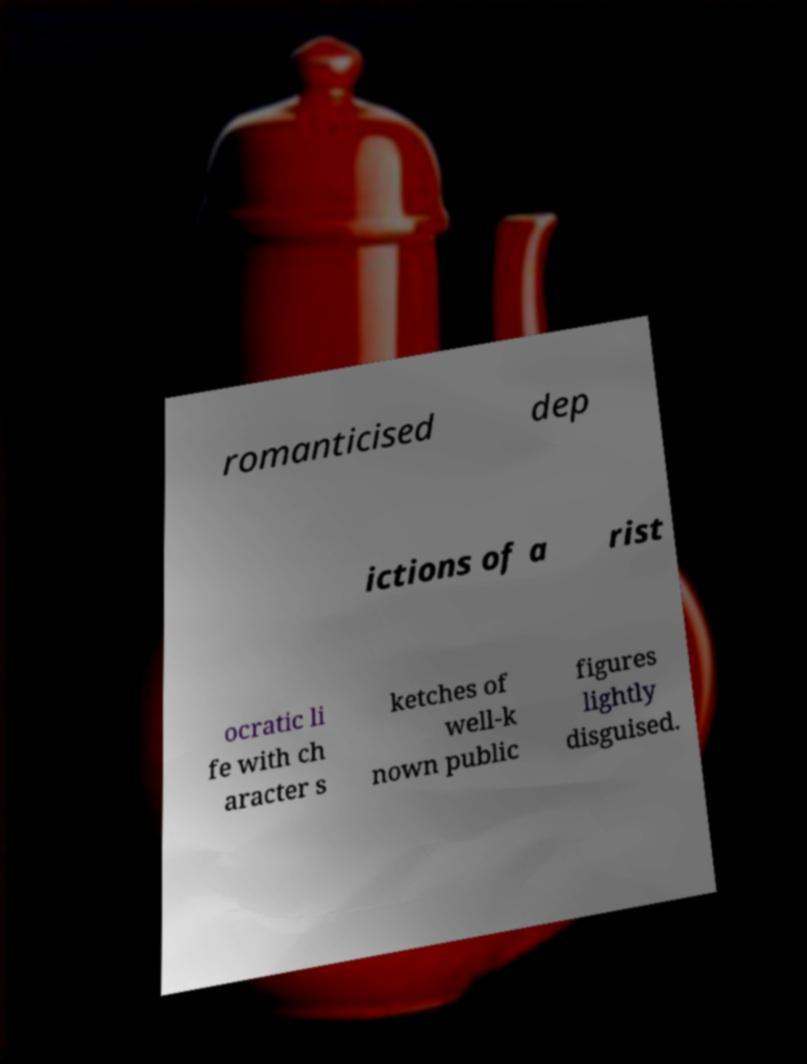What messages or text are displayed in this image? I need them in a readable, typed format. romanticised dep ictions of a rist ocratic li fe with ch aracter s ketches of well-k nown public figures lightly disguised. 